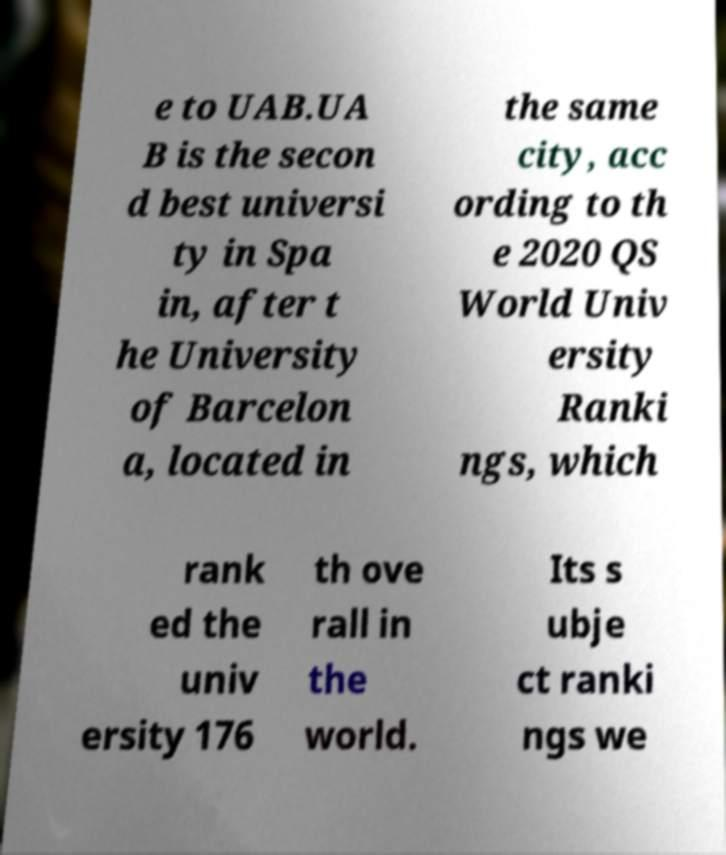Can you accurately transcribe the text from the provided image for me? e to UAB.UA B is the secon d best universi ty in Spa in, after t he University of Barcelon a, located in the same city, acc ording to th e 2020 QS World Univ ersity Ranki ngs, which rank ed the univ ersity 176 th ove rall in the world. Its s ubje ct ranki ngs we 